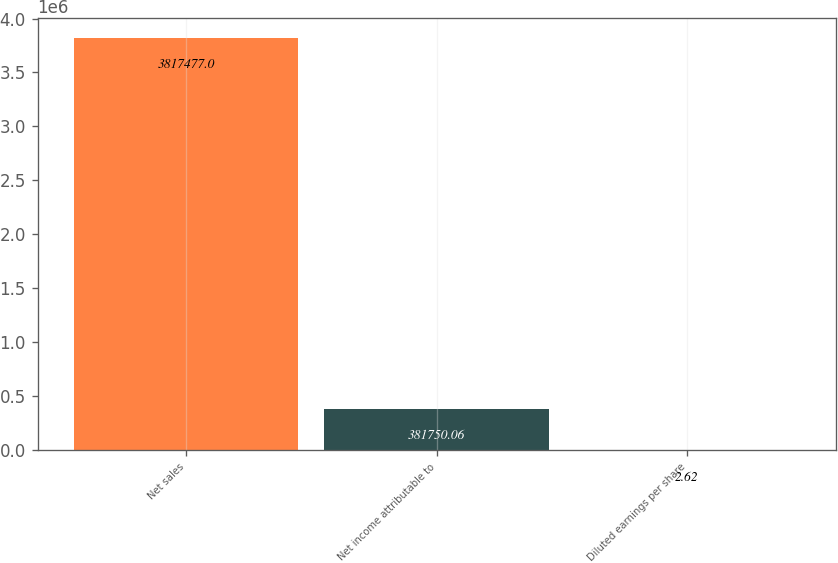Convert chart. <chart><loc_0><loc_0><loc_500><loc_500><bar_chart><fcel>Net sales<fcel>Net income attributable to<fcel>Diluted earnings per share<nl><fcel>3.81748e+06<fcel>381750<fcel>2.62<nl></chart> 